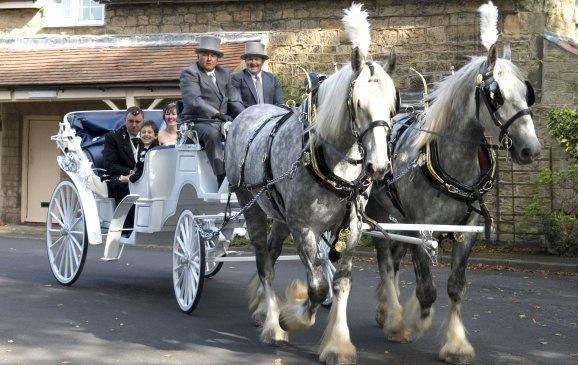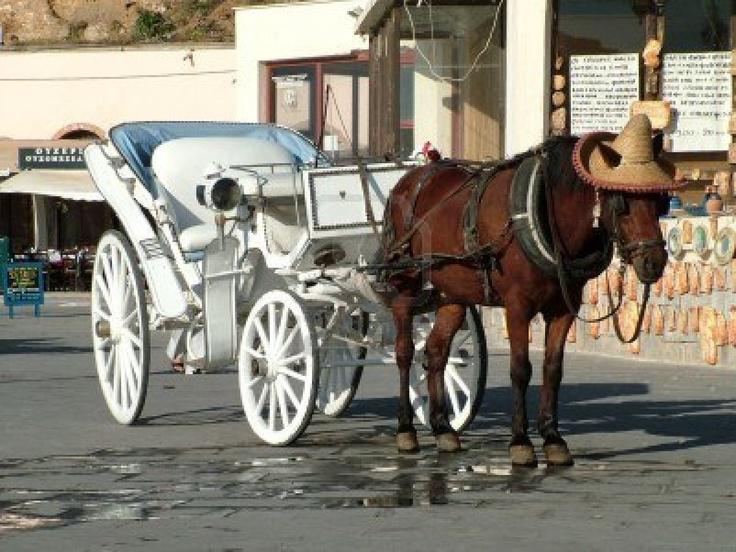The first image is the image on the left, the second image is the image on the right. Analyze the images presented: Is the assertion "One image features a four-wheeled cart pulled by just one horse." valid? Answer yes or no. Yes. The first image is the image on the left, the second image is the image on the right. Evaluate the accuracy of this statement regarding the images: "One of the images contains a white carriage.". Is it true? Answer yes or no. Yes. 